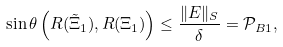<formula> <loc_0><loc_0><loc_500><loc_500>\sin \theta \left ( R ( \tilde { \Xi } _ { 1 } ) , R ( \Xi _ { 1 } ) \right ) \leq \frac { \| E \| _ { S } } { \delta } = { \mathcal { P } } _ { B 1 } ,</formula> 